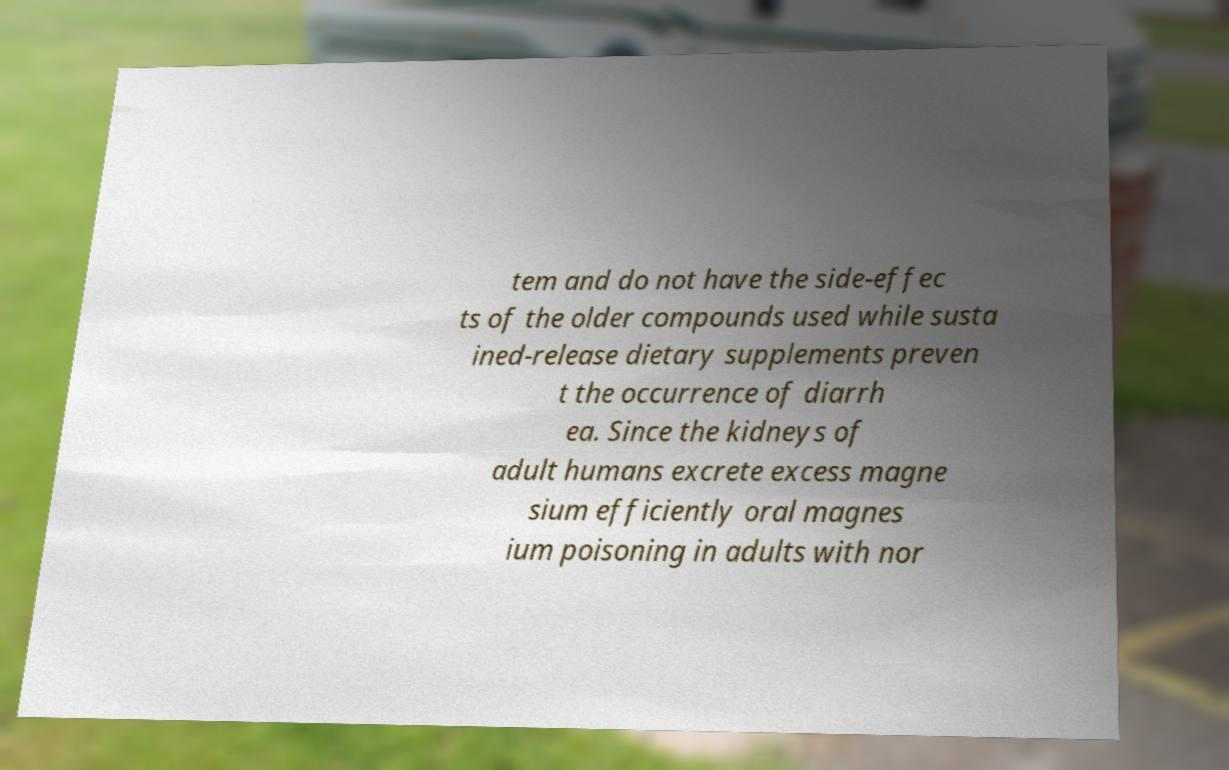Please identify and transcribe the text found in this image. tem and do not have the side-effec ts of the older compounds used while susta ined-release dietary supplements preven t the occurrence of diarrh ea. Since the kidneys of adult humans excrete excess magne sium efficiently oral magnes ium poisoning in adults with nor 